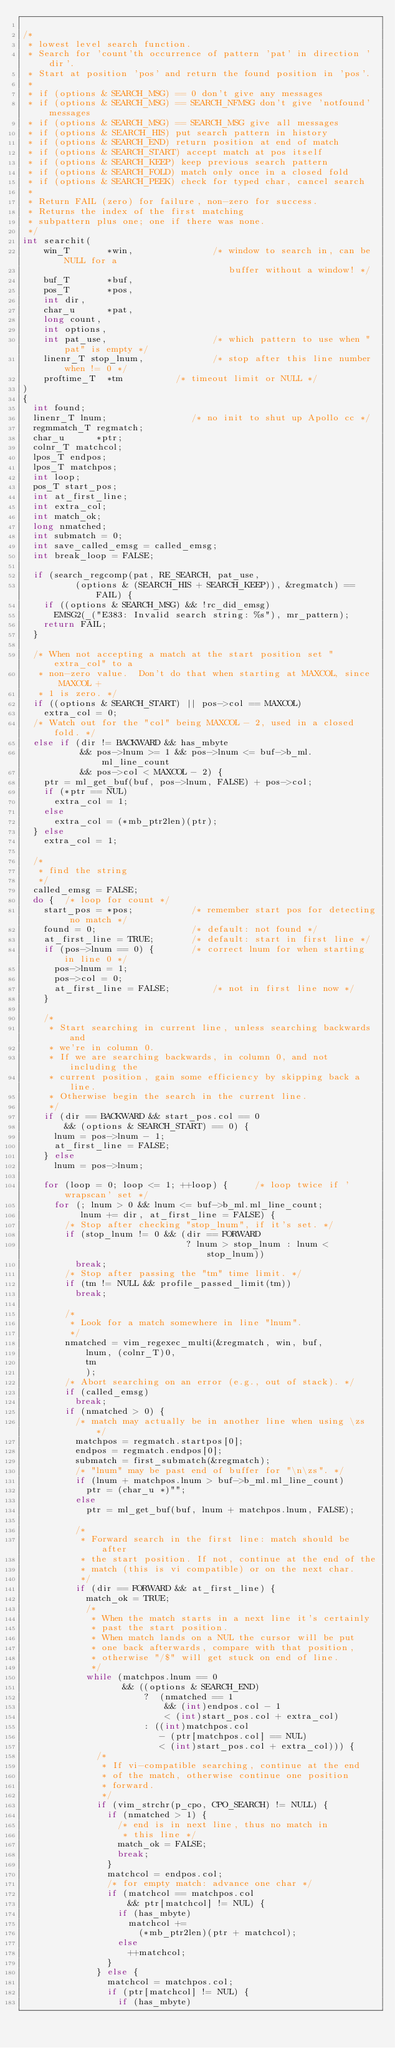Convert code to text. <code><loc_0><loc_0><loc_500><loc_500><_C_>
/*
 * lowest level search function.
 * Search for 'count'th occurrence of pattern 'pat' in direction 'dir'.
 * Start at position 'pos' and return the found position in 'pos'.
 *
 * if (options & SEARCH_MSG) == 0 don't give any messages
 * if (options & SEARCH_MSG) == SEARCH_NFMSG don't give 'notfound' messages
 * if (options & SEARCH_MSG) == SEARCH_MSG give all messages
 * if (options & SEARCH_HIS) put search pattern in history
 * if (options & SEARCH_END) return position at end of match
 * if (options & SEARCH_START) accept match at pos itself
 * if (options & SEARCH_KEEP) keep previous search pattern
 * if (options & SEARCH_FOLD) match only once in a closed fold
 * if (options & SEARCH_PEEK) check for typed char, cancel search
 *
 * Return FAIL (zero) for failure, non-zero for success.
 * Returns the index of the first matching
 * subpattern plus one; one if there was none.
 */
int searchit(
    win_T       *win,               /* window to search in, can be NULL for a
                                       buffer without a window! */
    buf_T       *buf,
    pos_T       *pos,
    int dir,
    char_u      *pat,
    long count,
    int options,
    int pat_use,                    /* which pattern to use when "pat" is empty */
    linenr_T stop_lnum,             /* stop after this line number when != 0 */
    proftime_T  *tm          /* timeout limit or NULL */
)
{
  int found;
  linenr_T lnum;                /* no init to shut up Apollo cc */
  regmmatch_T regmatch;
  char_u      *ptr;
  colnr_T matchcol;
  lpos_T endpos;
  lpos_T matchpos;
  int loop;
  pos_T start_pos;
  int at_first_line;
  int extra_col;
  int match_ok;
  long nmatched;
  int submatch = 0;
  int save_called_emsg = called_emsg;
  int break_loop = FALSE;

  if (search_regcomp(pat, RE_SEARCH, pat_use,
          (options & (SEARCH_HIS + SEARCH_KEEP)), &regmatch) == FAIL) {
    if ((options & SEARCH_MSG) && !rc_did_emsg)
      EMSG2(_("E383: Invalid search string: %s"), mr_pattern);
    return FAIL;
  }

  /* When not accepting a match at the start position set "extra_col" to a
   * non-zero value.  Don't do that when starting at MAXCOL, since MAXCOL +
   * 1 is zero. */
  if ((options & SEARCH_START) || pos->col == MAXCOL)
    extra_col = 0;
  /* Watch out for the "col" being MAXCOL - 2, used in a closed fold. */
  else if (dir != BACKWARD && has_mbyte
           && pos->lnum >= 1 && pos->lnum <= buf->b_ml.ml_line_count
           && pos->col < MAXCOL - 2) {
    ptr = ml_get_buf(buf, pos->lnum, FALSE) + pos->col;
    if (*ptr == NUL)
      extra_col = 1;
    else
      extra_col = (*mb_ptr2len)(ptr);
  } else
    extra_col = 1;

  /*
   * find the string
   */
  called_emsg = FALSE;
  do {  /* loop for count */
    start_pos = *pos;           /* remember start pos for detecting no match */
    found = 0;                  /* default: not found */
    at_first_line = TRUE;       /* default: start in first line */
    if (pos->lnum == 0) {       /* correct lnum for when starting in line 0 */
      pos->lnum = 1;
      pos->col = 0;
      at_first_line = FALSE;        /* not in first line now */
    }

    /*
     * Start searching in current line, unless searching backwards and
     * we're in column 0.
     * If we are searching backwards, in column 0, and not including the
     * current position, gain some efficiency by skipping back a line.
     * Otherwise begin the search in the current line.
     */
    if (dir == BACKWARD && start_pos.col == 0
        && (options & SEARCH_START) == 0) {
      lnum = pos->lnum - 1;
      at_first_line = FALSE;
    } else
      lnum = pos->lnum;

    for (loop = 0; loop <= 1; ++loop) {     /* loop twice if 'wrapscan' set */
      for (; lnum > 0 && lnum <= buf->b_ml.ml_line_count;
           lnum += dir, at_first_line = FALSE) {
        /* Stop after checking "stop_lnum", if it's set. */
        if (stop_lnum != 0 && (dir == FORWARD
                               ? lnum > stop_lnum : lnum < stop_lnum))
          break;
        /* Stop after passing the "tm" time limit. */
        if (tm != NULL && profile_passed_limit(tm))
          break;

        /*
         * Look for a match somewhere in line "lnum".
         */
        nmatched = vim_regexec_multi(&regmatch, win, buf,
            lnum, (colnr_T)0,
            tm
            );
        /* Abort searching on an error (e.g., out of stack). */
        if (called_emsg)
          break;
        if (nmatched > 0) {
          /* match may actually be in another line when using \zs */
          matchpos = regmatch.startpos[0];
          endpos = regmatch.endpos[0];
          submatch = first_submatch(&regmatch);
          /* "lnum" may be past end of buffer for "\n\zs". */
          if (lnum + matchpos.lnum > buf->b_ml.ml_line_count)
            ptr = (char_u *)"";
          else
            ptr = ml_get_buf(buf, lnum + matchpos.lnum, FALSE);

          /*
           * Forward search in the first line: match should be after
           * the start position. If not, continue at the end of the
           * match (this is vi compatible) or on the next char.
           */
          if (dir == FORWARD && at_first_line) {
            match_ok = TRUE;
            /*
             * When the match starts in a next line it's certainly
             * past the start position.
             * When match lands on a NUL the cursor will be put
             * one back afterwards, compare with that position,
             * otherwise "/$" will get stuck on end of line.
             */
            while (matchpos.lnum == 0
                   && ((options & SEARCH_END)
                       ?  (nmatched == 1
                           && (int)endpos.col - 1
                           < (int)start_pos.col + extra_col)
                       : ((int)matchpos.col
                          - (ptr[matchpos.col] == NUL)
                          < (int)start_pos.col + extra_col))) {
              /*
               * If vi-compatible searching, continue at the end
               * of the match, otherwise continue one position
               * forward.
               */
              if (vim_strchr(p_cpo, CPO_SEARCH) != NULL) {
                if (nmatched > 1) {
                  /* end is in next line, thus no match in
                   * this line */
                  match_ok = FALSE;
                  break;
                }
                matchcol = endpos.col;
                /* for empty match: advance one char */
                if (matchcol == matchpos.col
                    && ptr[matchcol] != NUL) {
                  if (has_mbyte)
                    matchcol +=
                      (*mb_ptr2len)(ptr + matchcol);
                  else
                    ++matchcol;
                }
              } else {
                matchcol = matchpos.col;
                if (ptr[matchcol] != NUL) {
                  if (has_mbyte)</code> 